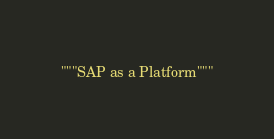<code> <loc_0><loc_0><loc_500><loc_500><_Python_>"""SAP as a Platform"""
</code> 